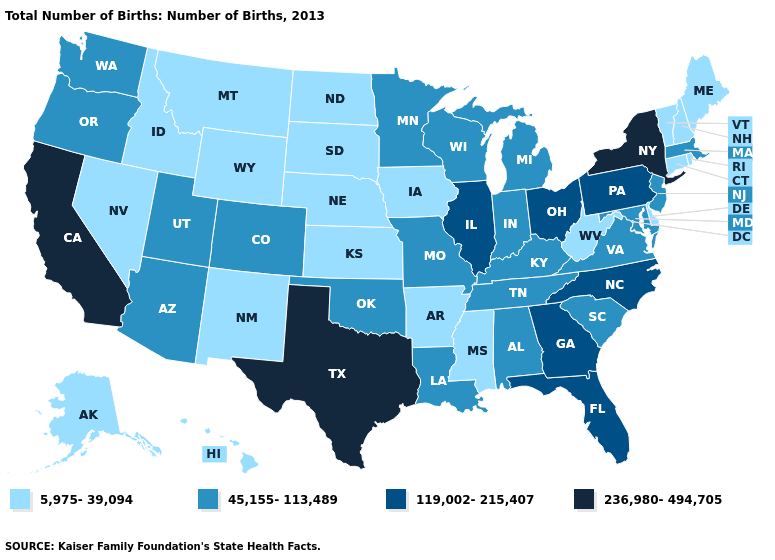Does the map have missing data?
Answer briefly. No. Which states have the lowest value in the West?
Quick response, please. Alaska, Hawaii, Idaho, Montana, Nevada, New Mexico, Wyoming. Among the states that border Alabama , does Mississippi have the lowest value?
Answer briefly. Yes. What is the value of Kansas?
Quick response, please. 5,975-39,094. Name the states that have a value in the range 45,155-113,489?
Concise answer only. Alabama, Arizona, Colorado, Indiana, Kentucky, Louisiana, Maryland, Massachusetts, Michigan, Minnesota, Missouri, New Jersey, Oklahoma, Oregon, South Carolina, Tennessee, Utah, Virginia, Washington, Wisconsin. Does California have a higher value than Pennsylvania?
Short answer required. Yes. Does Nevada have the highest value in the USA?
Give a very brief answer. No. Does Nevada have the highest value in the West?
Short answer required. No. What is the highest value in the USA?
Quick response, please. 236,980-494,705. What is the highest value in states that border South Dakota?
Write a very short answer. 45,155-113,489. What is the highest value in the USA?
Answer briefly. 236,980-494,705. Name the states that have a value in the range 45,155-113,489?
Be succinct. Alabama, Arizona, Colorado, Indiana, Kentucky, Louisiana, Maryland, Massachusetts, Michigan, Minnesota, Missouri, New Jersey, Oklahoma, Oregon, South Carolina, Tennessee, Utah, Virginia, Washington, Wisconsin. Name the states that have a value in the range 45,155-113,489?
Short answer required. Alabama, Arizona, Colorado, Indiana, Kentucky, Louisiana, Maryland, Massachusetts, Michigan, Minnesota, Missouri, New Jersey, Oklahoma, Oregon, South Carolina, Tennessee, Utah, Virginia, Washington, Wisconsin. Which states have the highest value in the USA?
Quick response, please. California, New York, Texas. Name the states that have a value in the range 45,155-113,489?
Short answer required. Alabama, Arizona, Colorado, Indiana, Kentucky, Louisiana, Maryland, Massachusetts, Michigan, Minnesota, Missouri, New Jersey, Oklahoma, Oregon, South Carolina, Tennessee, Utah, Virginia, Washington, Wisconsin. 